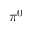Convert formula to latex. <formula><loc_0><loc_0><loc_500><loc_500>\pi ^ { 0 }</formula> 